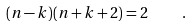Convert formula to latex. <formula><loc_0><loc_0><loc_500><loc_500>( n - k ) ( n + k + 2 ) = 2 \quad .</formula> 